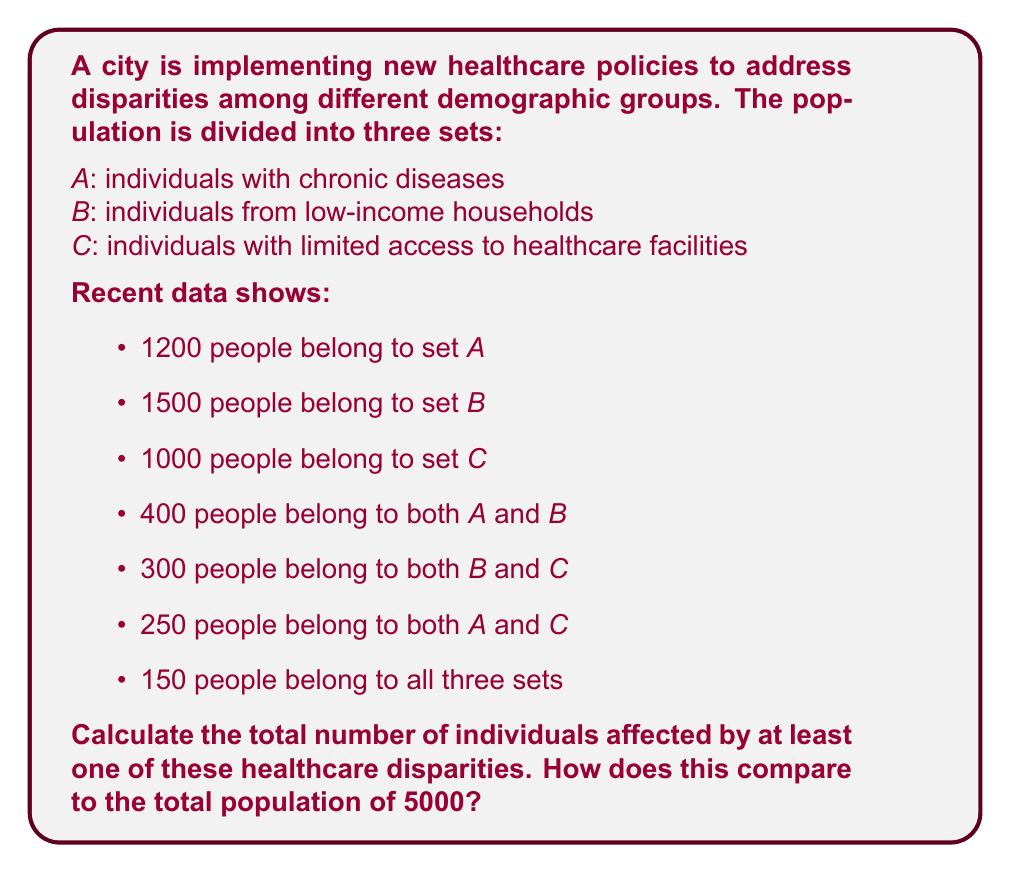Provide a solution to this math problem. To solve this problem, we'll use the principle of inclusion-exclusion for three sets. Let's break it down step-by-step:

1) First, let's define our universal set U as the total population: |U| = 5000

2) We're given:
   |A| = 1200, |B| = 1500, |C| = 1000
   |A ∩ B| = 400, |B ∩ C| = 300, |A ∩ C| = 250
   |A ∩ B ∩ C| = 150

3) The formula for the union of three sets is:

   $$|A ∪ B ∪ C| = |A| + |B| + |C| - |A ∩ B| - |B ∩ C| - |A ∩ C| + |A ∩ B ∩ C|$$

4) Let's substitute our values:

   $$|A ∪ B ∪ C| = 1200 + 1500 + 1000 - 400 - 300 - 250 + 150$$

5) Calculating:

   $$|A ∪ B ∪ C| = 3700 - 950 + 150 = 2900$$

6) Therefore, 2900 individuals are affected by at least one of these healthcare disparities.

7) To compare this to the total population:

   $$\frac{2900}{5000} \times 100\% = 58\%$$

Thus, 58% of the population is affected by at least one of these healthcare disparities.
Answer: 2900 individuals are affected by at least one of these healthcare disparities, which represents 58% of the total population. 